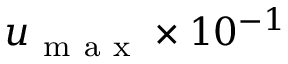Convert formula to latex. <formula><loc_0><loc_0><loc_500><loc_500>u _ { m a x } \times 1 0 ^ { - 1 }</formula> 